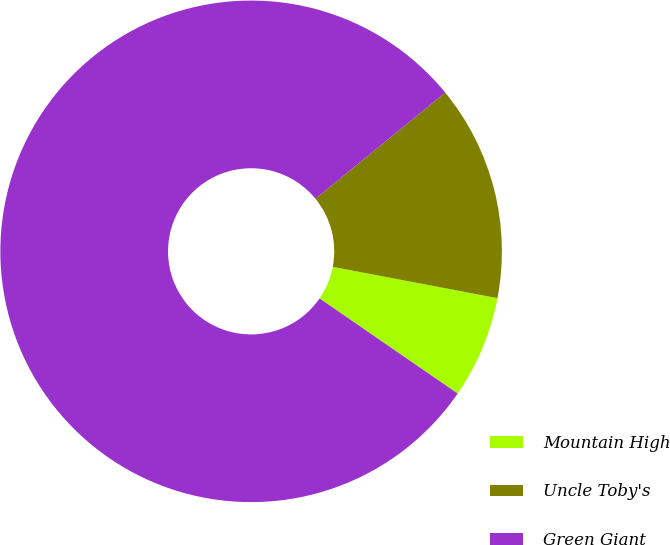<chart> <loc_0><loc_0><loc_500><loc_500><pie_chart><fcel>Mountain High<fcel>Uncle Toby's<fcel>Green Giant<nl><fcel>6.61%<fcel>13.9%<fcel>79.5%<nl></chart> 